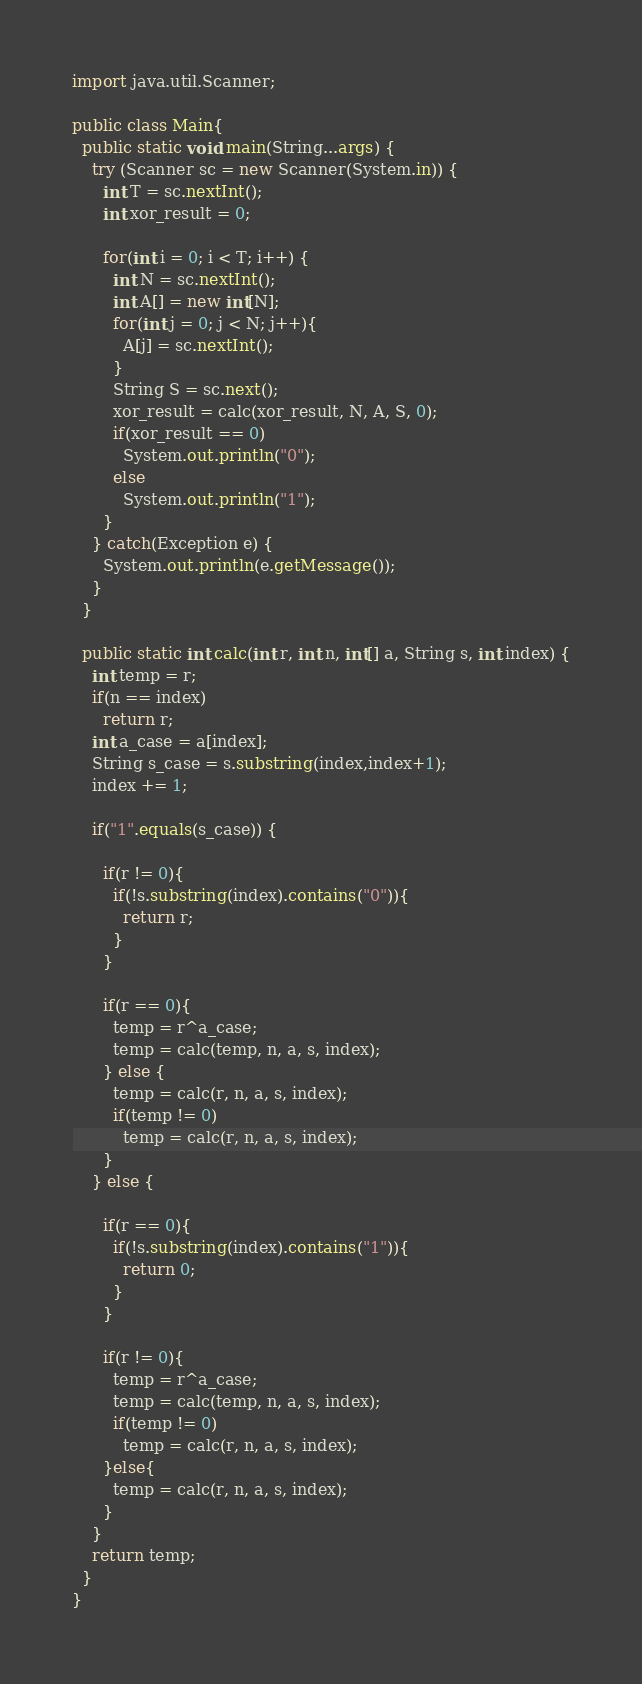<code> <loc_0><loc_0><loc_500><loc_500><_Java_>import java.util.Scanner;

public class Main{
  public static void main(String...args) {
    try (Scanner sc = new Scanner(System.in)) {
      int T = sc.nextInt();
      int xor_result = 0;
      
      for(int i = 0; i < T; i++) {
        int N = sc.nextInt();
        int A[] = new int[N];
        for(int j = 0; j < N; j++){
          A[j] = sc.nextInt();
        }
        String S = sc.next();
        xor_result = calc(xor_result, N, A, S, 0);
        if(xor_result == 0)
          System.out.println("0");
        else
          System.out.println("1");
      }
    } catch(Exception e) {
      System.out.println(e.getMessage());
    }
  }
  
  public static int calc(int r, int n, int[] a, String s, int index) {
    int temp = r;
    if(n == index)
      return r;
    int a_case = a[index];
    String s_case = s.substring(index,index+1);
    index += 1;
  
    if("1".equals(s_case)) {
    
      if(r != 0){
        if(!s.substring(index).contains("0")){
          return r;
        }
      }
      
      if(r == 0){
        temp = r^a_case;
        temp = calc(temp, n, a, s, index);
      } else {
        temp = calc(r, n, a, s, index);
        if(temp != 0)
          temp = calc(r, n, a, s, index);
      }
    } else {
    
      if(r == 0){
        if(!s.substring(index).contains("1")){
          return 0;
        }
      }
    
      if(r != 0){
        temp = r^a_case;
        temp = calc(temp, n, a, s, index);
        if(temp != 0)
          temp = calc(r, n, a, s, index);
      }else{
        temp = calc(r, n, a, s, index);
      }
    }
    return temp;
  }
}</code> 